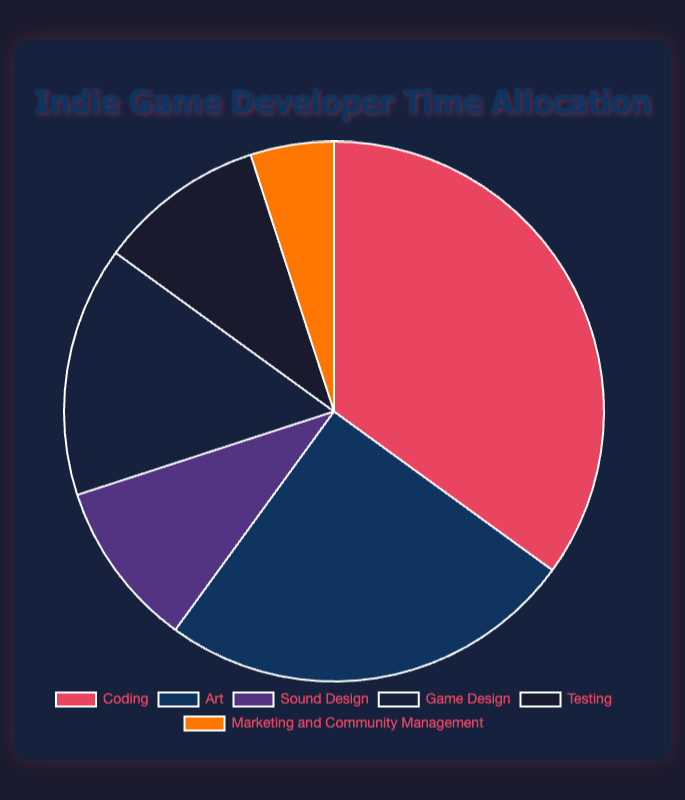Which task has the highest percentage of development time allocated to it? The pie chart shows that 'Coding' has the highest percentage with 35%.
Answer: Coding Which tasks have an equal percentage of development time allocated? The pie chart indicates that both 'Sound Design' and 'Testing' are allocated 10% each.
Answer: Sound Design and Testing What is the combined percentage of time allocated to Game Design and Marketing and Community Management? By adding the percentage for Game Design (15%) and Marketing and Community Management (5%), the total is 15% + 5% = 20%.
Answer: 20% How does the time allocated to Art compare with the time allocated to Testing? Art is allocated 25% of development time while Testing is allocated 10%, so Art has 15% more time allocated.
Answer: Art has 15% more time What percentage of development time is allocated to non-coding tasks? The non-coding tasks include Art (25%), Sound Design (10%), Game Design (15%), Testing (10%), and Marketing and Community Management (5%). Summing these gives 25% + 10% + 15% + 10% + 5% = 65%.
Answer: 65% What is the difference in percentages between the task with the highest allocation and the task with the lowest allocation? The highest allocation is for Coding (35%) and the lowest is for Marketing and Community Management (5%). The difference is 35% - 5% = 30%.
Answer: 30% Which task has a lower percentage of time allocation than Game Design but higher than Testing? Game Design has 15%, and testing has 10%. Sound Design, with 10%, fits this range.
Answer: Sound Design What is the average percentage of time allocated to Sound Design and Testing? The percentages for Sound Design and Testing are both 10%. The average is (10% + 10%) / 2 = 10%.
Answer: 10% If you combine the time allocated to Coding and Art, what percentage of total development time does that represent? Coding is 35% and Art is 25%. Adding these together gives 35% + 25% = 60%.
Answer: 60% What is the combined percentage of time allocated to all creative tasks (Art, Sound Design, Game Design)? Summing the percentages for Art (25%), Sound Design (10%), and Game Design (15%) gives 25% + 10% + 15% = 50%.
Answer: 50% 